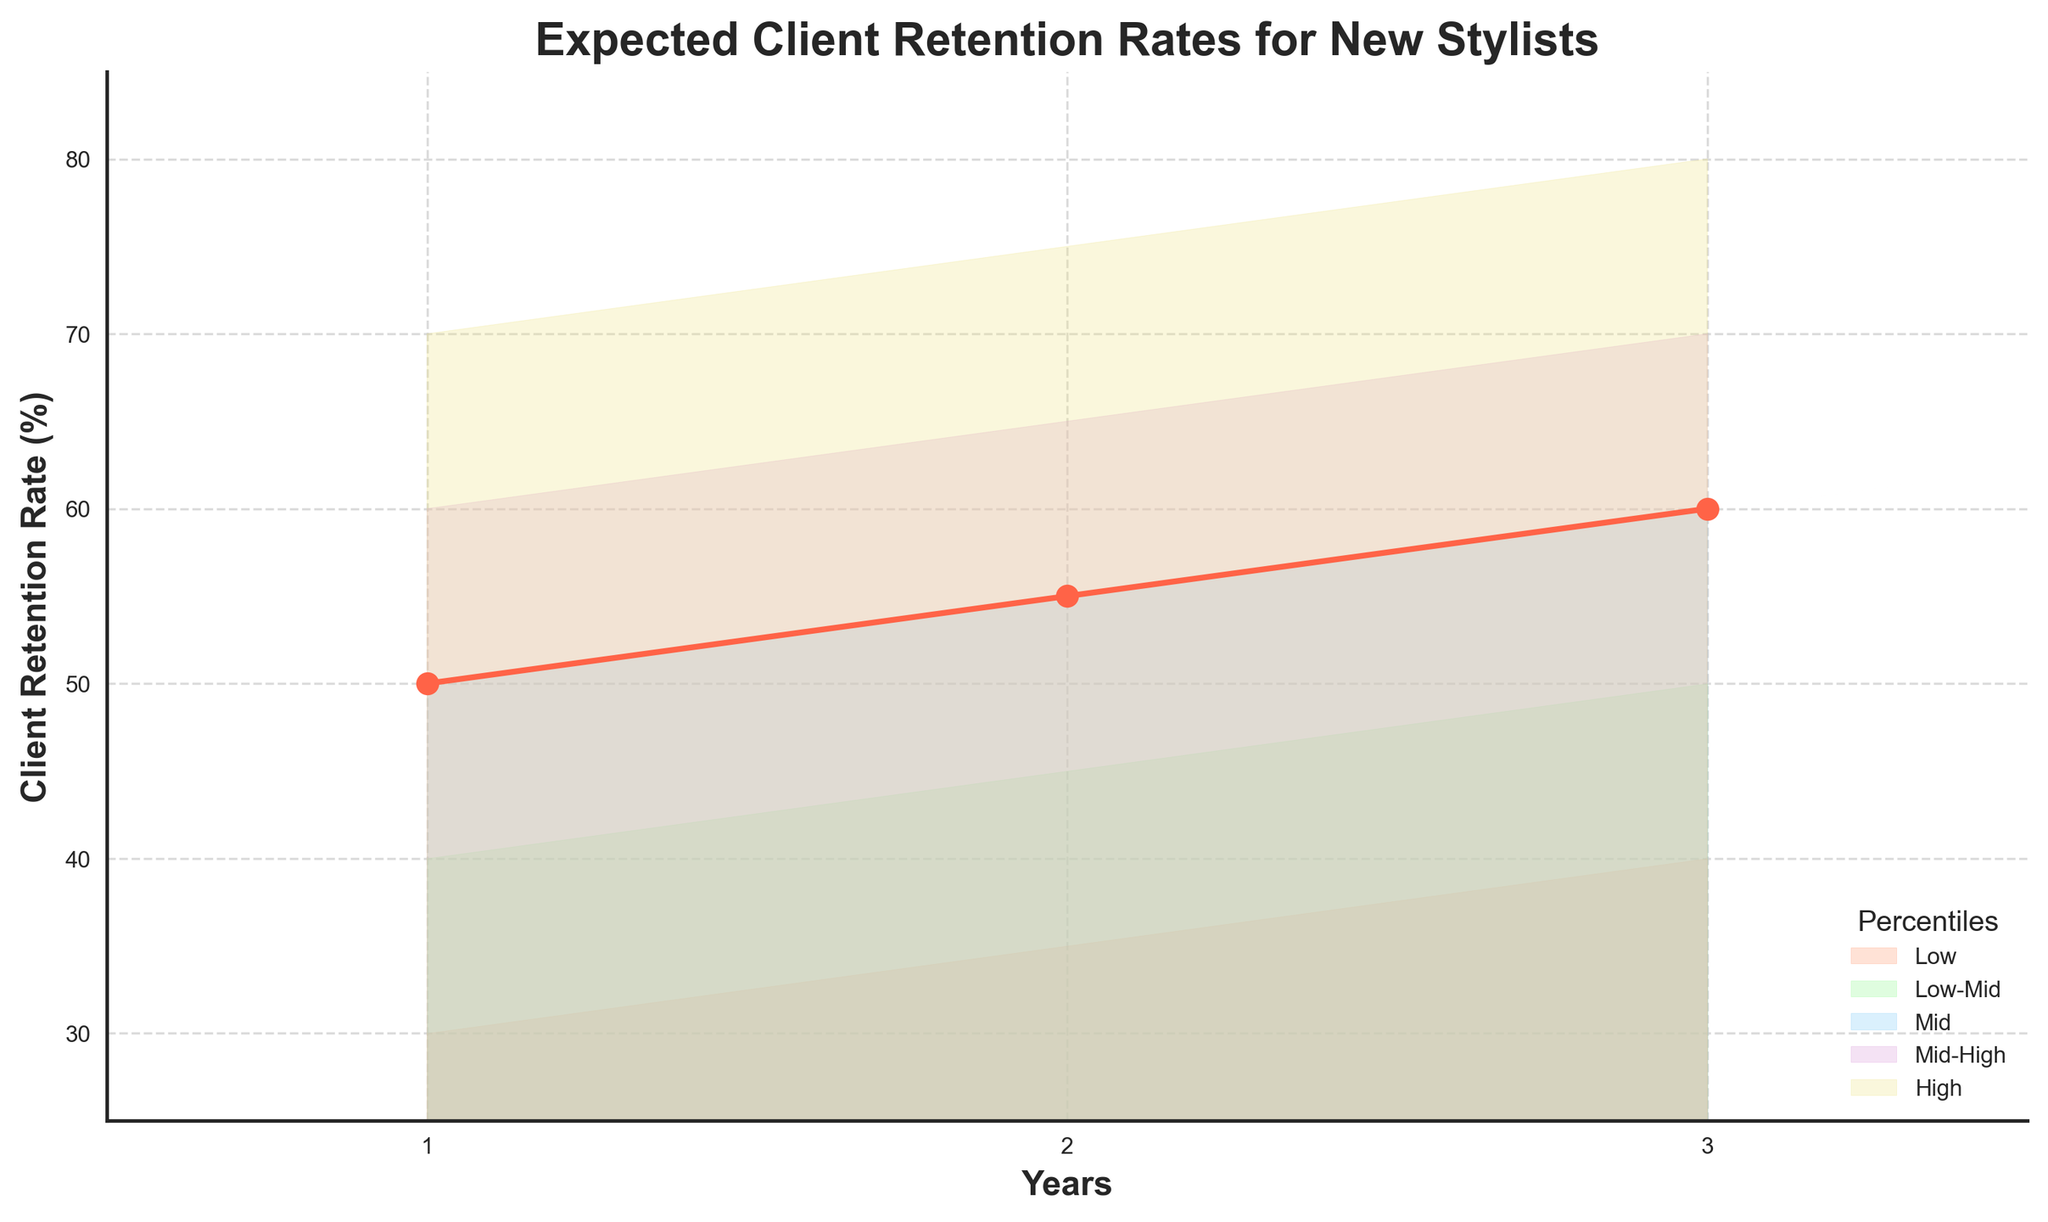What is the title of the chart? The title can be seen at the top of the chart, which provides a clear summary of the data being presented.
Answer: Expected Client Retention Rates for New Stylists What range of years does the chart cover? The years are labeled on the x-axis, showing the span from the start to the end of the period being analyzed.
Answer: 1 to 3 years What is the retention rate for the "Mid" percentile in the first year? The retention rates are plotted as lines and marked with points for each year. For the "Mid" percentile, follow the line for the first year.
Answer: 50% Which percentile has the highest retention rate in the third year? By looking at the lines representing each percentile, identify the one that has the highest value in the third year.
Answer: High How does the "Low-Mid" percentile change from the first to the second year? Compare the retention rates for the "Low-Mid" percentile between the first and second years. Subtract the first year's rate from the second year's rate.
Answer: Increases by 5% What is the average retention rate for the "Mid" percentile over the three years? Sum the "Mid" retention rates for each year and divide by the number of years. (50 + 55 + 60) / 3 = 55
Answer: 55% Which year shows the biggest improvement in retention rates for the "Low" percentile? Compare the year-to-year changes in the "Low" percentile. Calculate the difference for each interval and identify the largest one: (35-30)=5, (40-35)=5. Both are the same, so any can be chosen.
Answer: From year 1 to year 2 How are the color shades used in the chart to represent different percentiles? Identify the colors associated with each percentile band by looking at the filled areas within the chart.
Answer: Light salmon, light green, light blue, light purple, light yellow Which percentile shows the least variability in retention rates over three years? Compare the ranges of the retention rates for each percentile over the three years and identify the one with the smallest range.
Answer: Low-Mid What overall trend is observed in the "High" percentile from year 1 to year 3? Track the "High" percentile line over the three years and describe whether it consistently increases, decreases, or fluctuates.
Answer: Consistently increases 